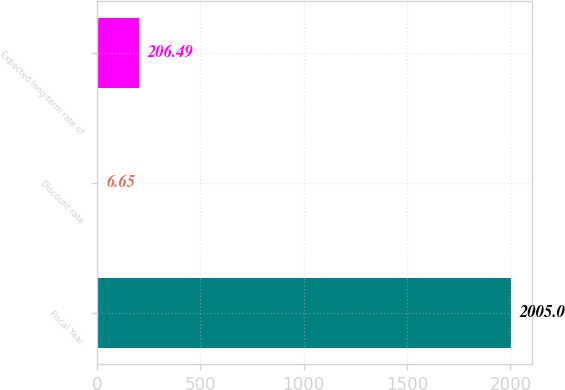<chart> <loc_0><loc_0><loc_500><loc_500><bar_chart><fcel>Fiscal Year<fcel>Discount rate<fcel>Expected long-term rate of<nl><fcel>2005<fcel>6.65<fcel>206.49<nl></chart> 